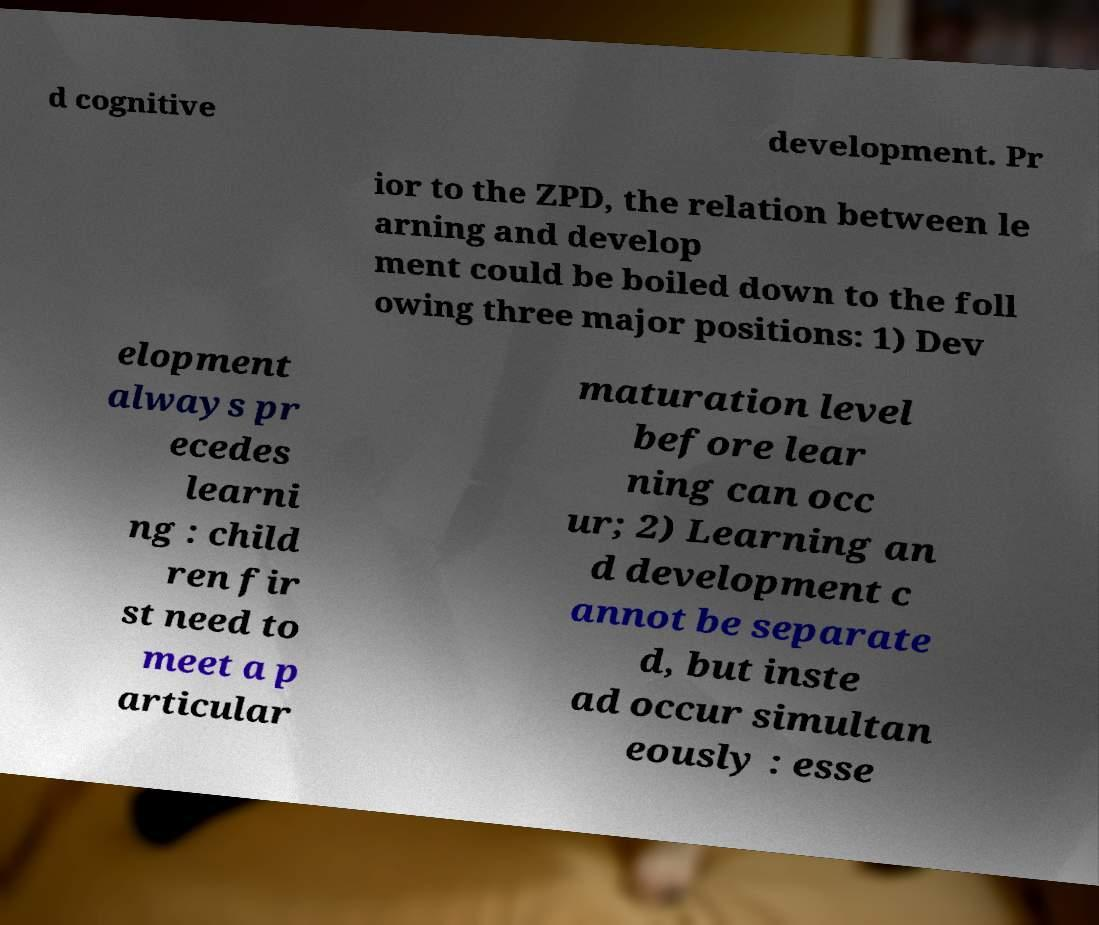There's text embedded in this image that I need extracted. Can you transcribe it verbatim? d cognitive development. Pr ior to the ZPD, the relation between le arning and develop ment could be boiled down to the foll owing three major positions: 1) Dev elopment always pr ecedes learni ng : child ren fir st need to meet a p articular maturation level before lear ning can occ ur; 2) Learning an d development c annot be separate d, but inste ad occur simultan eously : esse 